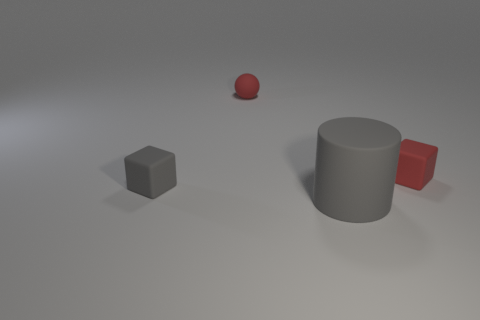Is there a small gray block that has the same material as the cylinder?
Offer a terse response. Yes. What is the color of the small matte object that is to the left of the tiny red thing behind the small red thing that is in front of the tiny red ball?
Offer a very short reply. Gray. Are the small red object that is in front of the red matte sphere and the gray thing to the left of the matte cylinder made of the same material?
Your response must be concise. Yes. There is a tiny matte object in front of the tiny red matte cube; what shape is it?
Give a very brief answer. Cube. How many objects are either tiny red matte balls or matte blocks on the right side of the sphere?
Make the answer very short. 2. Do the tiny red ball and the big gray thing have the same material?
Ensure brevity in your answer.  Yes. Is the number of small objects behind the small sphere the same as the number of large gray objects that are in front of the large gray rubber thing?
Ensure brevity in your answer.  Yes. There is a big gray thing; how many gray rubber objects are on the left side of it?
Ensure brevity in your answer.  1. What number of things are either large blue rubber objects or large rubber cylinders?
Give a very brief answer. 1. How many red spheres have the same size as the red matte block?
Provide a succinct answer. 1. 